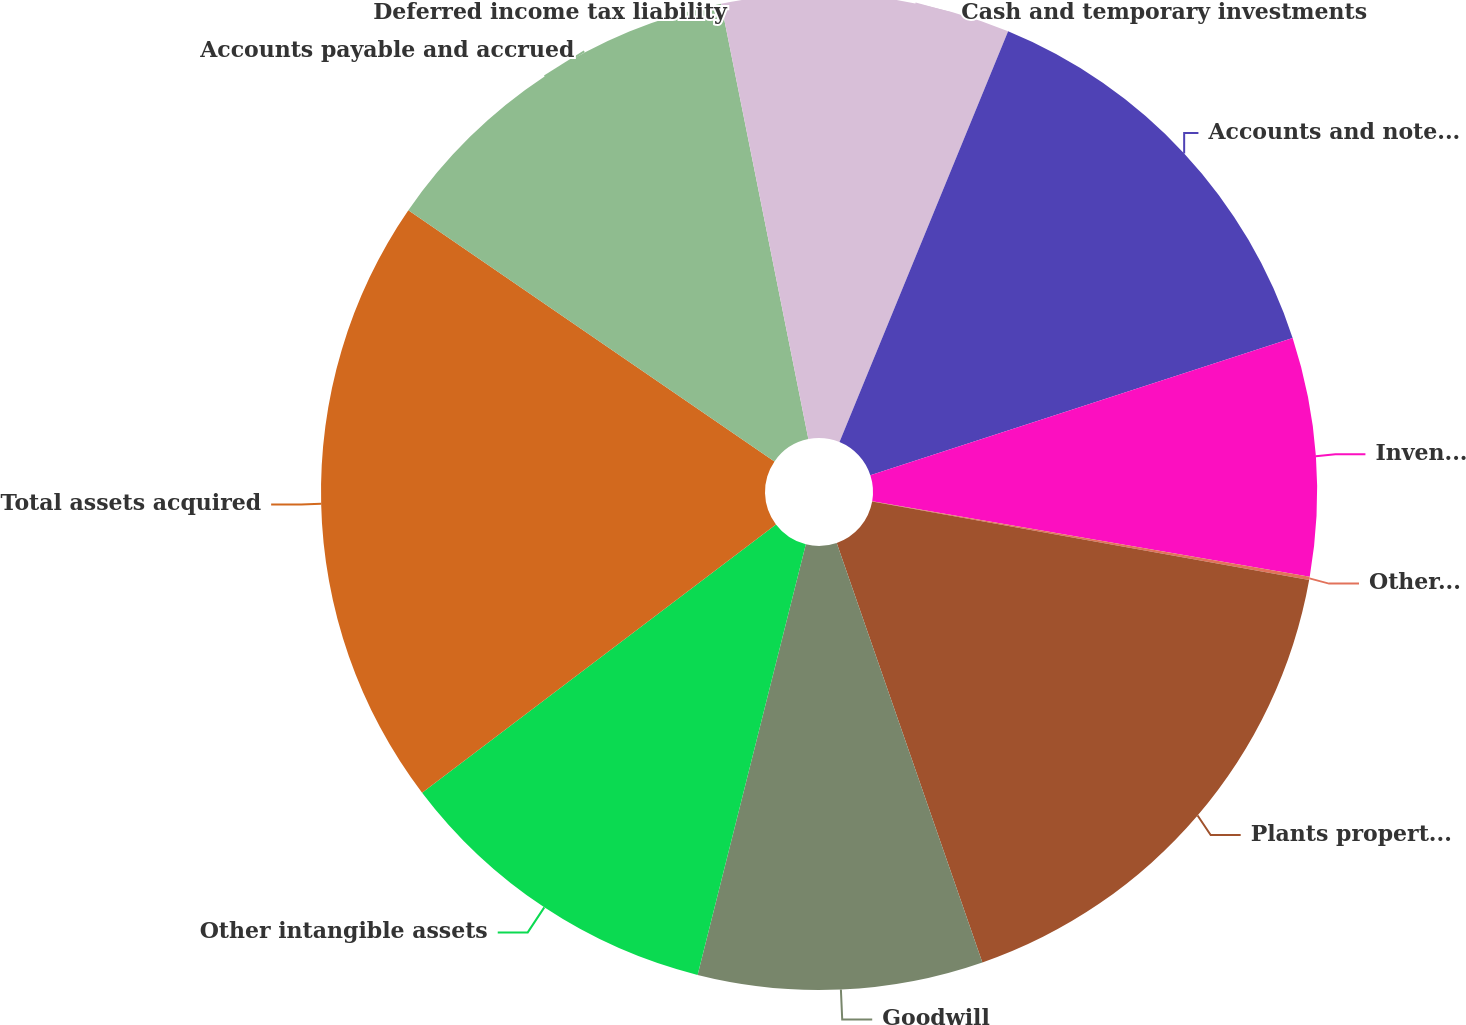<chart> <loc_0><loc_0><loc_500><loc_500><pie_chart><fcel>Cash and temporary investments<fcel>Accounts and notes receivable<fcel>Inventory<fcel>Other current assets<fcel>Plants properties and<fcel>Goodwill<fcel>Other intangible assets<fcel>Total assets acquired<fcel>Accounts payable and accrued<fcel>Deferred income tax liability<nl><fcel>6.2%<fcel>13.8%<fcel>7.72%<fcel>0.11%<fcel>16.85%<fcel>9.24%<fcel>10.76%<fcel>19.89%<fcel>12.28%<fcel>3.15%<nl></chart> 